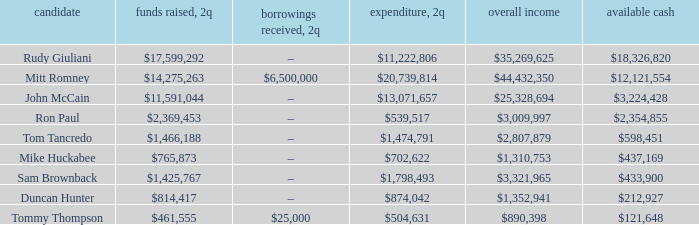Name the money raised when 2Q has money spent and 2Q is $874,042 $814,417. 